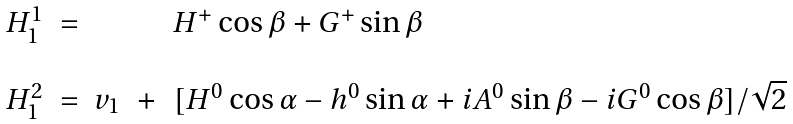Convert formula to latex. <formula><loc_0><loc_0><loc_500><loc_500>\begin{array} { r c l c l } H _ { 1 } ^ { 1 } & = & & & H ^ { + } \cos \beta + G ^ { + } \sin \beta \\ \\ H _ { 1 } ^ { 2 } & = & v _ { 1 } & + & [ H ^ { 0 } \cos \alpha - h ^ { 0 } \sin \alpha + i A ^ { 0 } \sin \beta - i G ^ { 0 } \cos \beta ] / \sqrt { 2 } \end{array}</formula> 